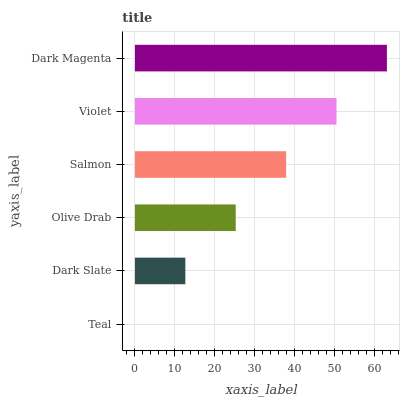Is Teal the minimum?
Answer yes or no. Yes. Is Dark Magenta the maximum?
Answer yes or no. Yes. Is Dark Slate the minimum?
Answer yes or no. No. Is Dark Slate the maximum?
Answer yes or no. No. Is Dark Slate greater than Teal?
Answer yes or no. Yes. Is Teal less than Dark Slate?
Answer yes or no. Yes. Is Teal greater than Dark Slate?
Answer yes or no. No. Is Dark Slate less than Teal?
Answer yes or no. No. Is Salmon the high median?
Answer yes or no. Yes. Is Olive Drab the low median?
Answer yes or no. Yes. Is Olive Drab the high median?
Answer yes or no. No. Is Salmon the low median?
Answer yes or no. No. 